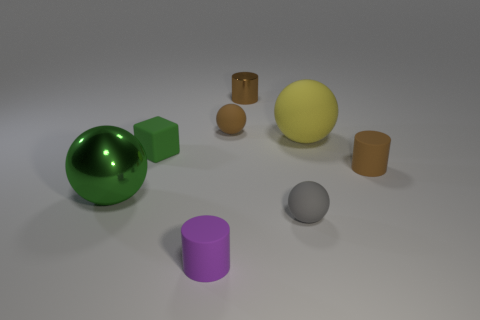What is the shape of the metal thing that is in front of the brown matte thing that is right of the small brown metallic cylinder?
Your answer should be compact. Sphere. Are there fewer green metal balls in front of the small gray ball than large purple metallic cubes?
Make the answer very short. No. What is the shape of the large thing that is the same color as the rubber block?
Ensure brevity in your answer.  Sphere. What number of red matte spheres have the same size as the rubber block?
Your answer should be compact. 0. The tiny brown rubber thing that is behind the large yellow object has what shape?
Make the answer very short. Sphere. Is the number of cyan things less than the number of small brown balls?
Your response must be concise. Yes. Is there anything else that has the same color as the small matte cube?
Provide a succinct answer. Yes. How big is the brown rubber object behind the tiny matte block?
Offer a very short reply. Small. Is the number of yellow metal cubes greater than the number of brown matte spheres?
Your response must be concise. No. What is the yellow ball made of?
Provide a short and direct response. Rubber. 